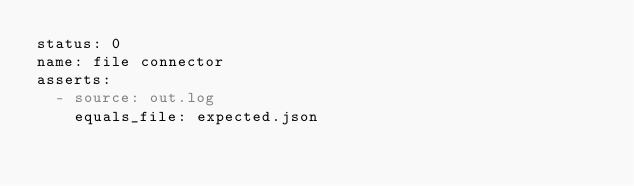Convert code to text. <code><loc_0><loc_0><loc_500><loc_500><_YAML_>status: 0
name: file connector
asserts:
  - source: out.log
    equals_file: expected.json</code> 